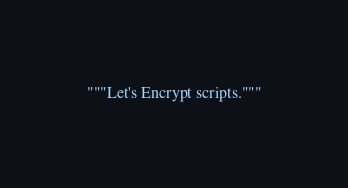Convert code to text. <code><loc_0><loc_0><loc_500><loc_500><_Python_>"""Let's Encrypt scripts."""
</code> 